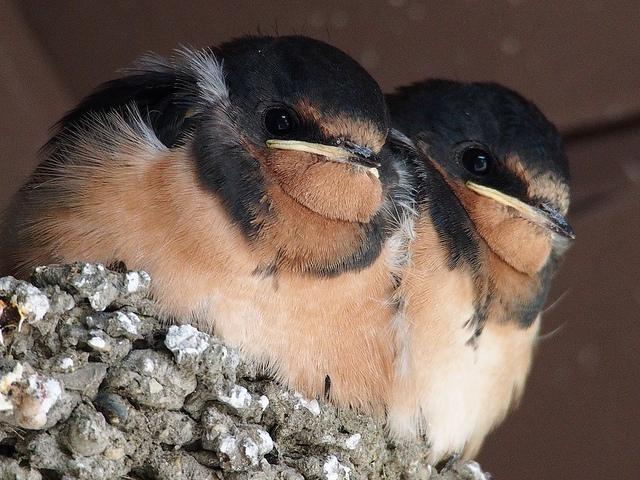How many are there?
Give a very brief answer. 2. How many animals are shown?
Give a very brief answer. 2. How many birds can you see?
Give a very brief answer. 2. 